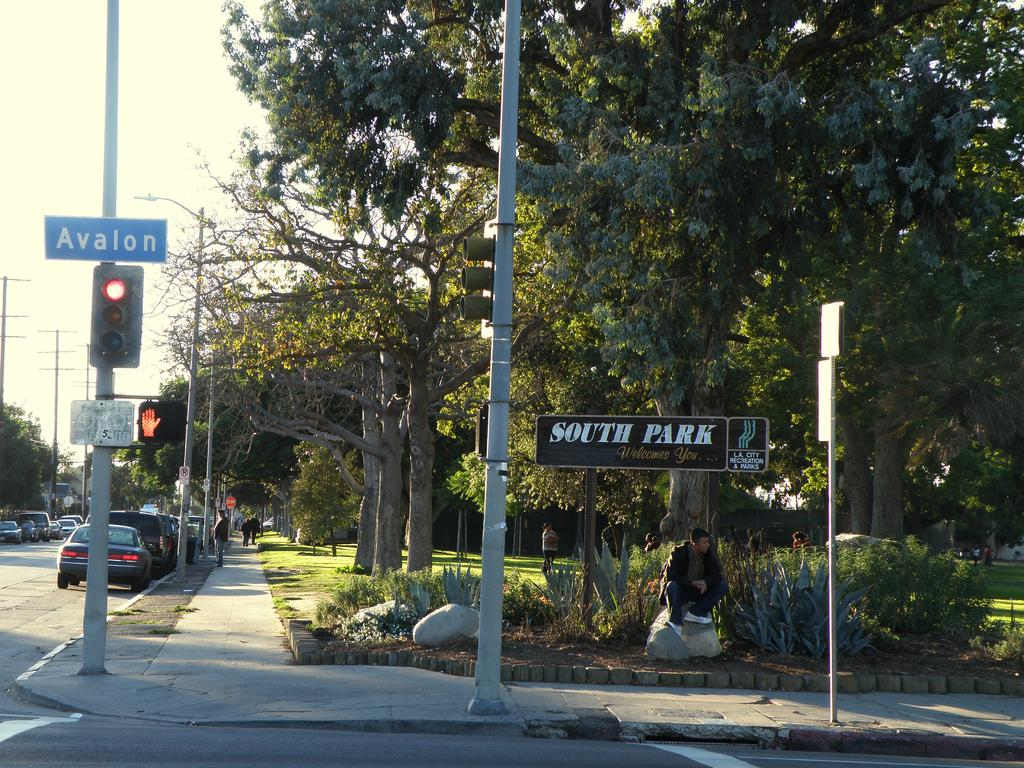<image>
Present a compact description of the photo's key features. A blue street sign that says avalon above a red light. 